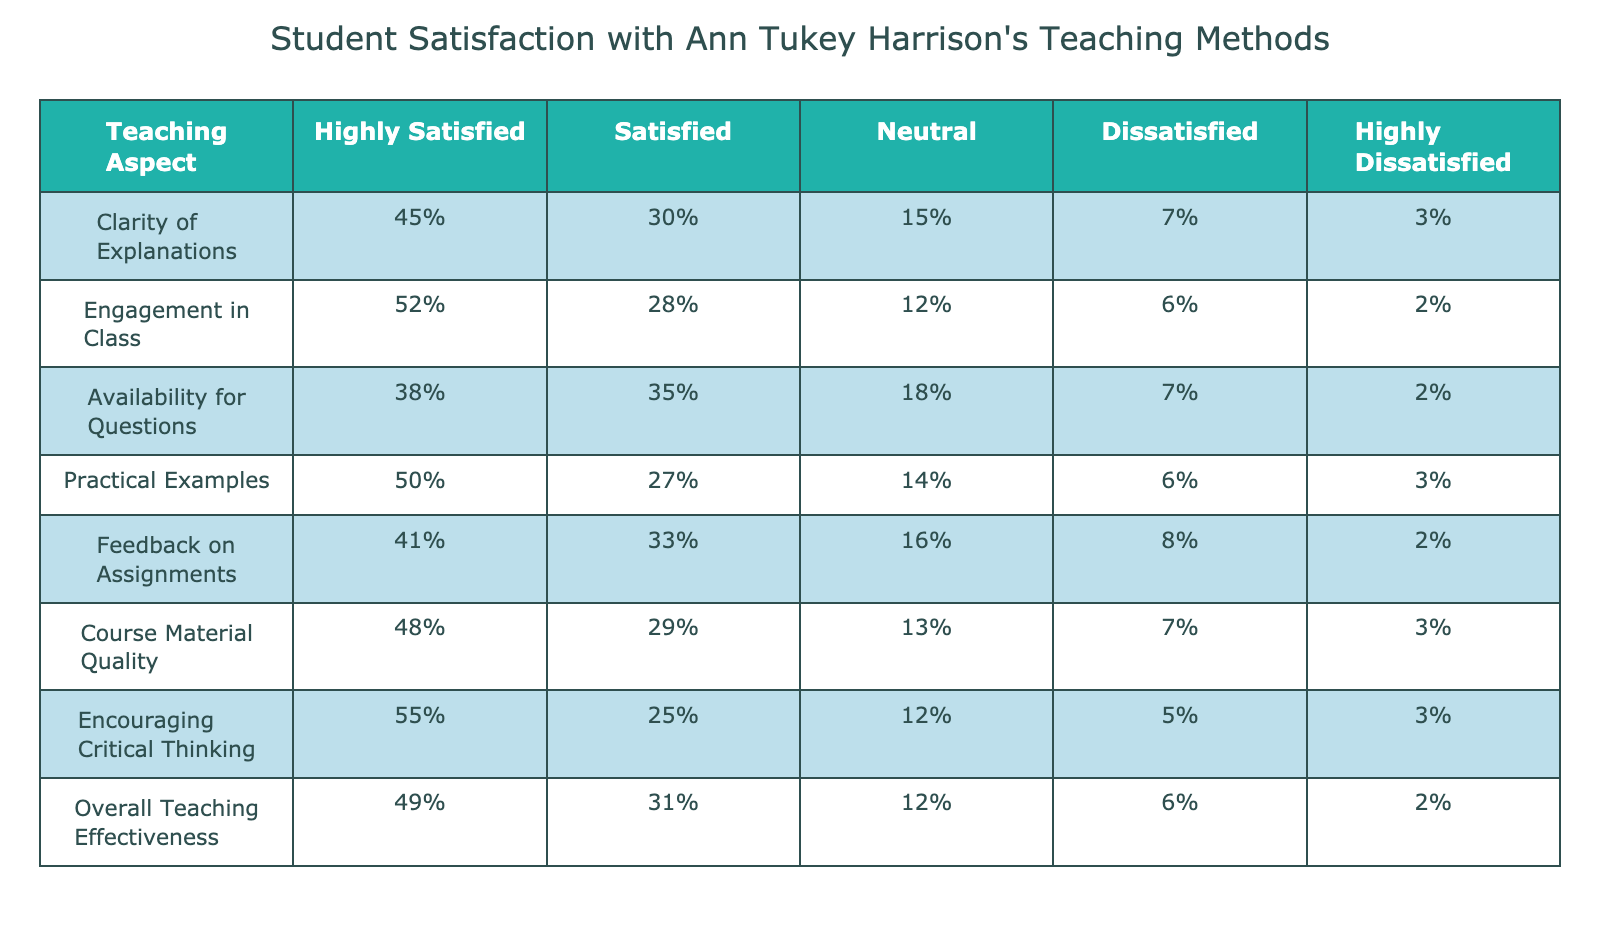What percentage of students were highly satisfied with the clarity of explanations? The table shows that 45% of students indicated they were highly satisfied with the clarity of explanations.
Answer: 45% Which teaching aspect received the highest percentage of students who were highly satisfied? The highest percentage of highly satisfied students is for the aspect 'Encouraging Critical Thinking' at 55%.
Answer: 55% What is the combined percentage of students who were either satisfied or highly satisfied with the course material quality? To find the combined percentage, we add the 'Highly Satisfied' (48%) and 'Satisfied' (29%) percentages for course material quality: 48 + 29 = 77%.
Answer: 77% Did more than half of the students report being highly satisfied with engagement in class? The percentage of students who were highly satisfied with engagement in class is 52%, which is greater than half (50%).
Answer: Yes What is the average percentage of students who reported being satisfied with all teaching aspects listed in the table? We first sum the 'Satisfied' percentages: 30% + 28% + 35% + 27% + 33% + 29% + 25% + 31% = 238%. There are 8 aspects, so we calculate the average: 238% / 8 = 29.75%.
Answer: 29.75% 